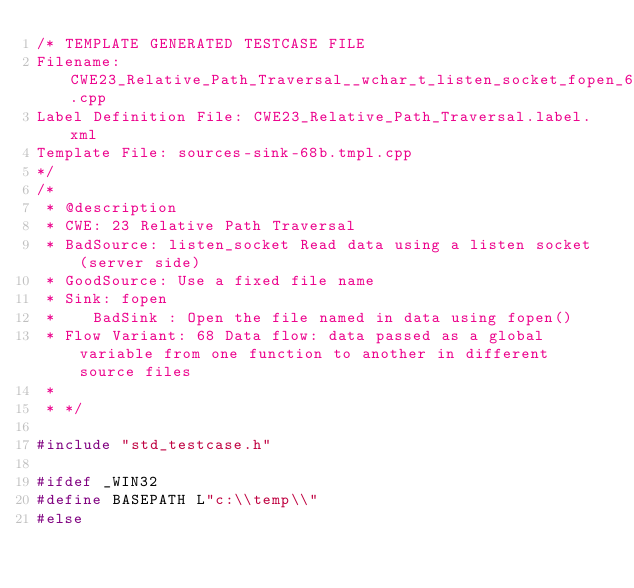Convert code to text. <code><loc_0><loc_0><loc_500><loc_500><_C++_>/* TEMPLATE GENERATED TESTCASE FILE
Filename: CWE23_Relative_Path_Traversal__wchar_t_listen_socket_fopen_68b.cpp
Label Definition File: CWE23_Relative_Path_Traversal.label.xml
Template File: sources-sink-68b.tmpl.cpp
*/
/*
 * @description
 * CWE: 23 Relative Path Traversal
 * BadSource: listen_socket Read data using a listen socket (server side)
 * GoodSource: Use a fixed file name
 * Sink: fopen
 *    BadSink : Open the file named in data using fopen()
 * Flow Variant: 68 Data flow: data passed as a global variable from one function to another in different source files
 *
 * */

#include "std_testcase.h"

#ifdef _WIN32
#define BASEPATH L"c:\\temp\\"
#else</code> 